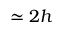<formula> <loc_0><loc_0><loc_500><loc_500>\simeq 2 h</formula> 